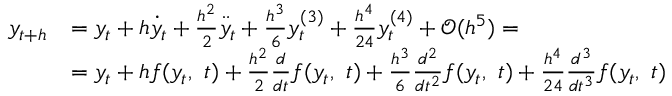<formula> <loc_0><loc_0><loc_500><loc_500>{ \begin{array} { r l } { y _ { t + h } } & { = y _ { t } + h { \dot { y } } _ { t } + { \frac { h ^ { 2 } } { 2 } } { \ddot { y } } _ { t } + { \frac { h ^ { 3 } } { 6 } } y _ { t } ^ { ( 3 ) } + { \frac { h ^ { 4 } } { 2 4 } } y _ { t } ^ { ( 4 ) } + { \mathcal { O } } ( h ^ { 5 } ) = } \\ & { = y _ { t } + h f ( y _ { t } , \ t ) + { \frac { h ^ { 2 } } { 2 } } { \frac { d } { d t } } f ( y _ { t } , \ t ) + { \frac { h ^ { 3 } } { 6 } } { \frac { d ^ { 2 } } { d t ^ { 2 } } } f ( y _ { t } , \ t ) + { \frac { h ^ { 4 } } { 2 4 } } { \frac { d ^ { 3 } } { d t ^ { 3 } } } f ( y _ { t } , \ t ) } \end{array} }</formula> 